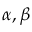Convert formula to latex. <formula><loc_0><loc_0><loc_500><loc_500>\alpha , \beta</formula> 